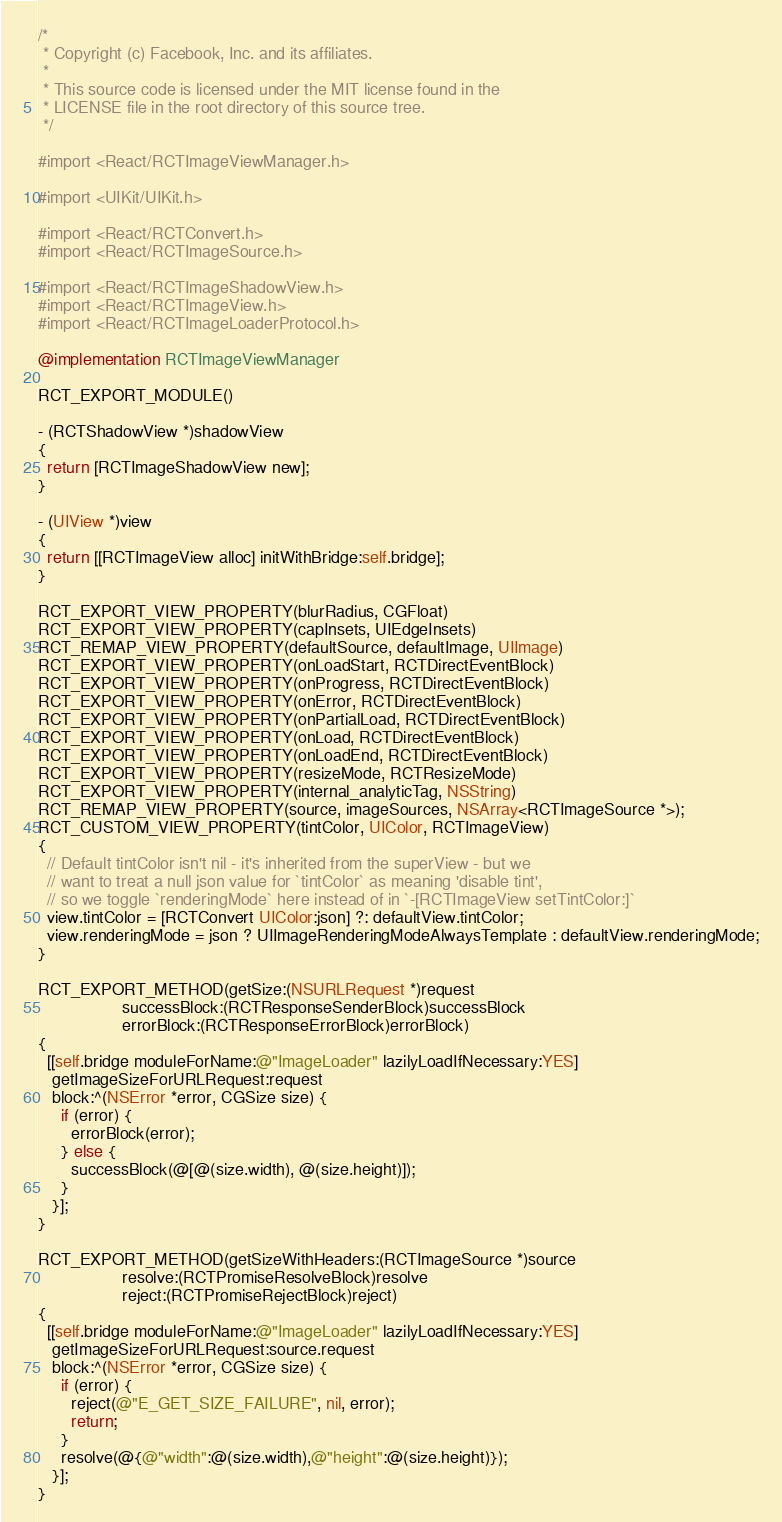Convert code to text. <code><loc_0><loc_0><loc_500><loc_500><_ObjectiveC_>/*
 * Copyright (c) Facebook, Inc. and its affiliates.
 *
 * This source code is licensed under the MIT license found in the
 * LICENSE file in the root directory of this source tree.
 */

#import <React/RCTImageViewManager.h>

#import <UIKit/UIKit.h>

#import <React/RCTConvert.h>
#import <React/RCTImageSource.h>

#import <React/RCTImageShadowView.h>
#import <React/RCTImageView.h>
#import <React/RCTImageLoaderProtocol.h>

@implementation RCTImageViewManager

RCT_EXPORT_MODULE()

- (RCTShadowView *)shadowView
{
  return [RCTImageShadowView new];
}

- (UIView *)view
{
  return [[RCTImageView alloc] initWithBridge:self.bridge];
}

RCT_EXPORT_VIEW_PROPERTY(blurRadius, CGFloat)
RCT_EXPORT_VIEW_PROPERTY(capInsets, UIEdgeInsets)
RCT_REMAP_VIEW_PROPERTY(defaultSource, defaultImage, UIImage)
RCT_EXPORT_VIEW_PROPERTY(onLoadStart, RCTDirectEventBlock)
RCT_EXPORT_VIEW_PROPERTY(onProgress, RCTDirectEventBlock)
RCT_EXPORT_VIEW_PROPERTY(onError, RCTDirectEventBlock)
RCT_EXPORT_VIEW_PROPERTY(onPartialLoad, RCTDirectEventBlock)
RCT_EXPORT_VIEW_PROPERTY(onLoad, RCTDirectEventBlock)
RCT_EXPORT_VIEW_PROPERTY(onLoadEnd, RCTDirectEventBlock)
RCT_EXPORT_VIEW_PROPERTY(resizeMode, RCTResizeMode)
RCT_EXPORT_VIEW_PROPERTY(internal_analyticTag, NSString)
RCT_REMAP_VIEW_PROPERTY(source, imageSources, NSArray<RCTImageSource *>);
RCT_CUSTOM_VIEW_PROPERTY(tintColor, UIColor, RCTImageView)
{
  // Default tintColor isn't nil - it's inherited from the superView - but we
  // want to treat a null json value for `tintColor` as meaning 'disable tint',
  // so we toggle `renderingMode` here instead of in `-[RCTImageView setTintColor:]`
  view.tintColor = [RCTConvert UIColor:json] ?: defaultView.tintColor;
  view.renderingMode = json ? UIImageRenderingModeAlwaysTemplate : defaultView.renderingMode;
}

RCT_EXPORT_METHOD(getSize:(NSURLRequest *)request
                  successBlock:(RCTResponseSenderBlock)successBlock
                  errorBlock:(RCTResponseErrorBlock)errorBlock)
{
  [[self.bridge moduleForName:@"ImageLoader" lazilyLoadIfNecessary:YES]
   getImageSizeForURLRequest:request
   block:^(NSError *error, CGSize size) {
     if (error) {
       errorBlock(error);
     } else {
       successBlock(@[@(size.width), @(size.height)]);
     }
   }];
}

RCT_EXPORT_METHOD(getSizeWithHeaders:(RCTImageSource *)source
                  resolve:(RCTPromiseResolveBlock)resolve
                  reject:(RCTPromiseRejectBlock)reject)
{
  [[self.bridge moduleForName:@"ImageLoader" lazilyLoadIfNecessary:YES]
   getImageSizeForURLRequest:source.request
   block:^(NSError *error, CGSize size) {
     if (error) {
       reject(@"E_GET_SIZE_FAILURE", nil, error);
       return;
     }
     resolve(@{@"width":@(size.width),@"height":@(size.height)});
   }];
}
</code> 